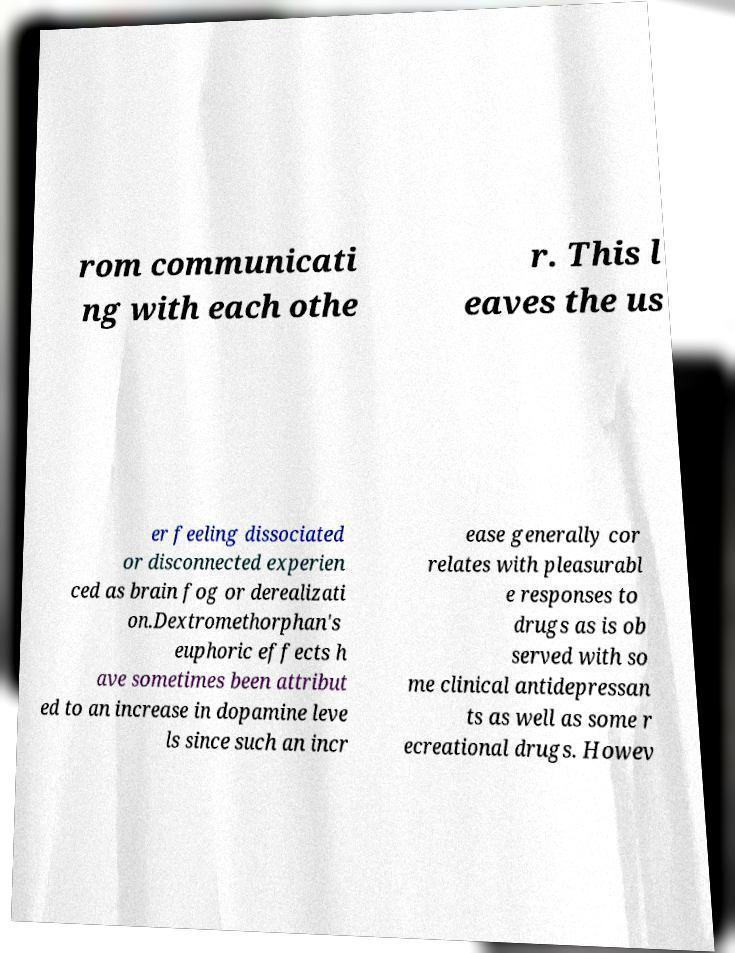There's text embedded in this image that I need extracted. Can you transcribe it verbatim? rom communicati ng with each othe r. This l eaves the us er feeling dissociated or disconnected experien ced as brain fog or derealizati on.Dextromethorphan's euphoric effects h ave sometimes been attribut ed to an increase in dopamine leve ls since such an incr ease generally cor relates with pleasurabl e responses to drugs as is ob served with so me clinical antidepressan ts as well as some r ecreational drugs. Howev 